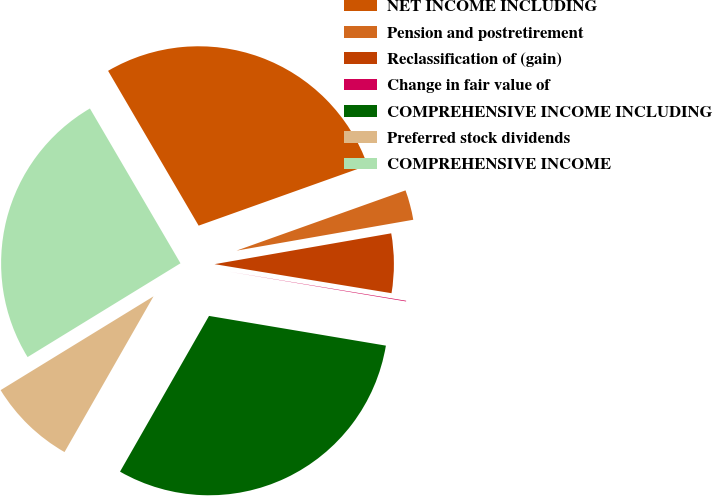<chart> <loc_0><loc_0><loc_500><loc_500><pie_chart><fcel>NET INCOME INCLUDING<fcel>Pension and postretirement<fcel>Reclassification of (gain)<fcel>Change in fair value of<fcel>COMPREHENSIVE INCOME INCLUDING<fcel>Preferred stock dividends<fcel>COMPREHENSIVE INCOME<nl><fcel>27.97%<fcel>2.7%<fcel>5.34%<fcel>0.06%<fcel>30.61%<fcel>7.98%<fcel>25.33%<nl></chart> 